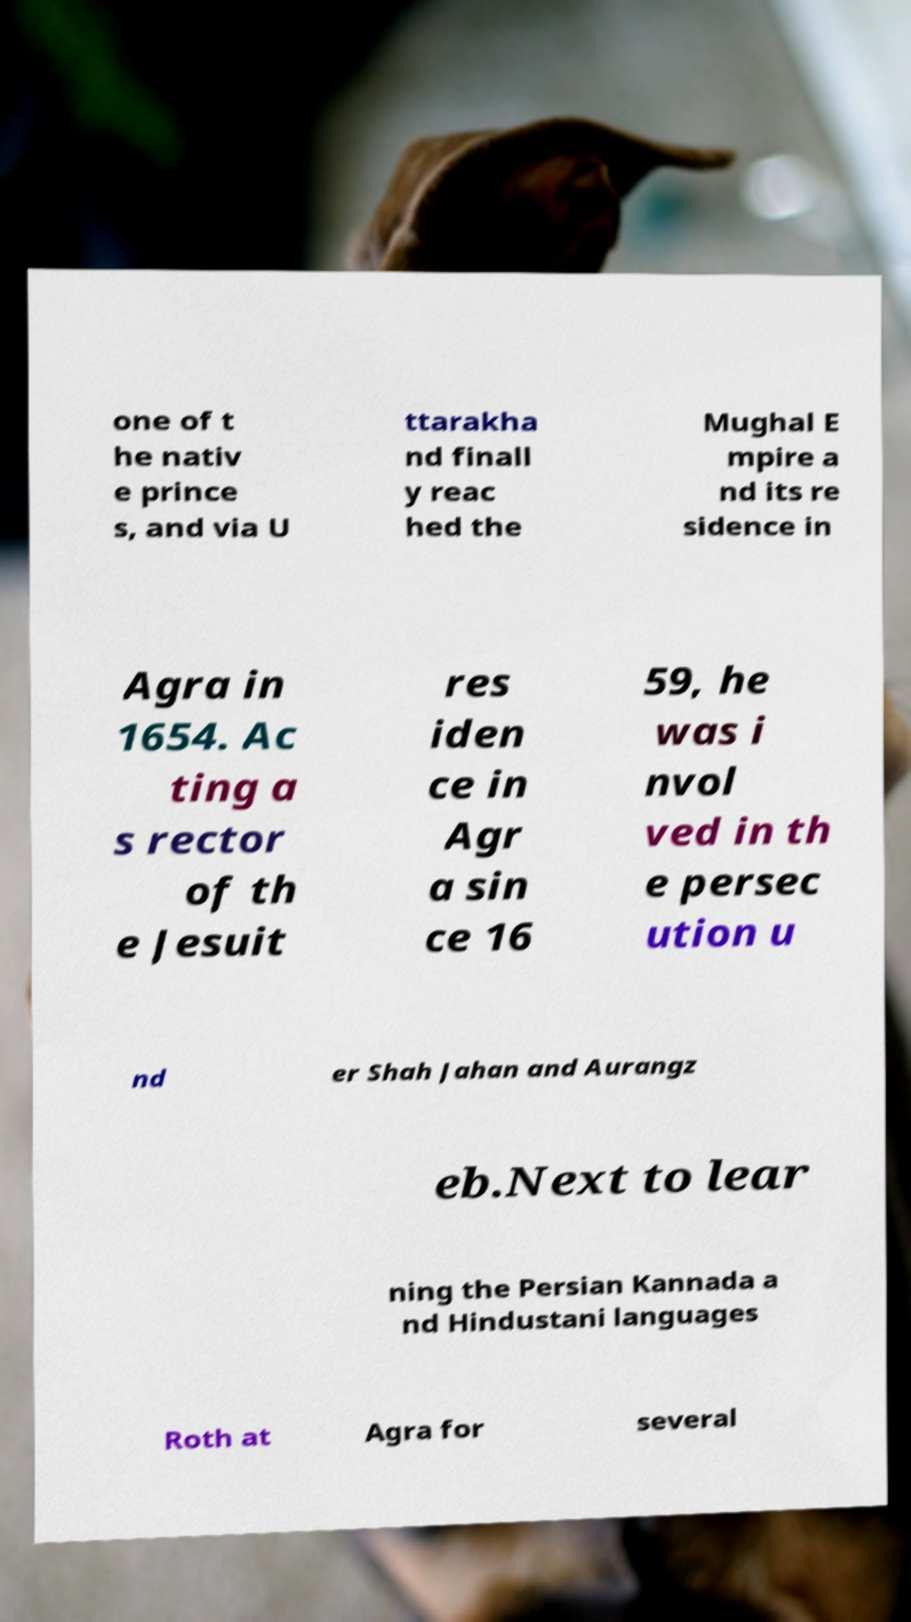Could you extract and type out the text from this image? one of t he nativ e prince s, and via U ttarakha nd finall y reac hed the Mughal E mpire a nd its re sidence in Agra in 1654. Ac ting a s rector of th e Jesuit res iden ce in Agr a sin ce 16 59, he was i nvol ved in th e persec ution u nd er Shah Jahan and Aurangz eb.Next to lear ning the Persian Kannada a nd Hindustani languages Roth at Agra for several 